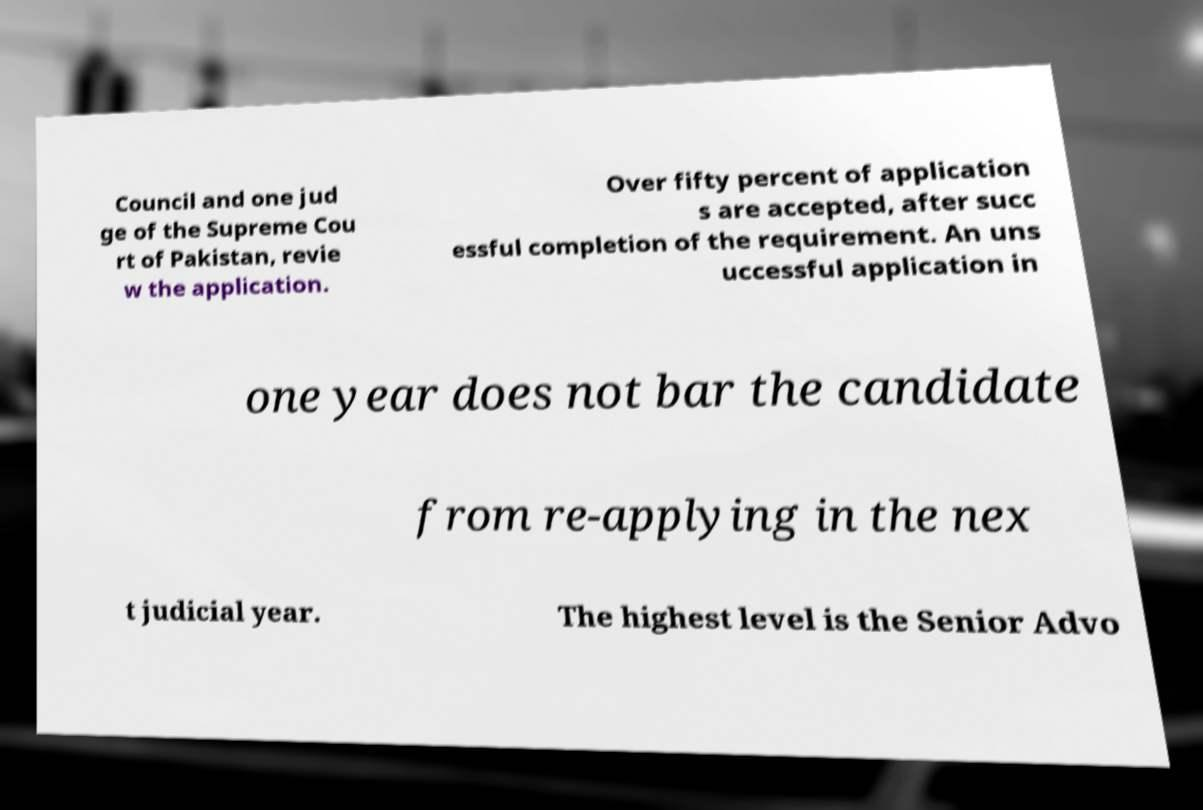Can you accurately transcribe the text from the provided image for me? Council and one jud ge of the Supreme Cou rt of Pakistan, revie w the application. Over fifty percent of application s are accepted, after succ essful completion of the requirement. An uns uccessful application in one year does not bar the candidate from re-applying in the nex t judicial year. The highest level is the Senior Advo 